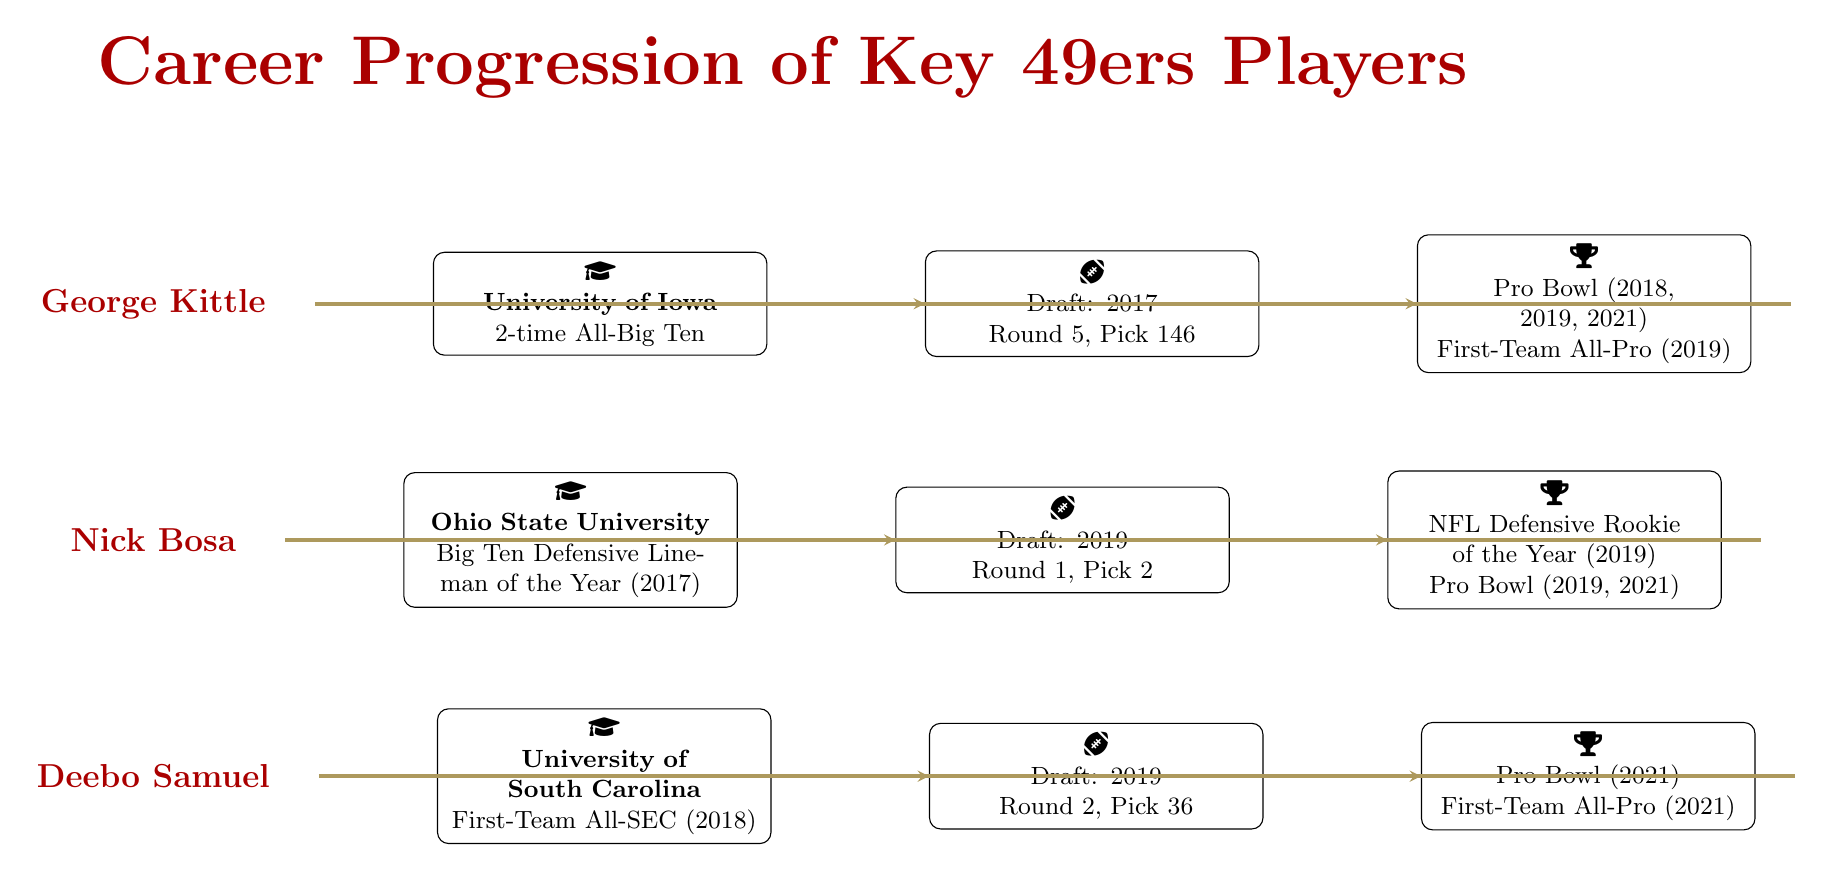What is the college of George Kittle? The diagram indicates that George Kittle attended the University of Iowa, as seen in the section corresponding to his college career.
Answer: University of Iowa How many Pro Bowl selections does Nick Bosa have? The milestone section for Nick Bosa lists his Pro Bowl selections as 2019 and 2021, which are two separate years. Therefore, he has two Pro Bowl selections.
Answer: 2 What year was Deebo Samuel drafted? The draft selection section for Deebo Samuel states the year he was drafted is 2019. Thus, the answer is directly pulled from that section of the diagram.
Answer: 2019 Which player has the highest draft pick number? The diagram shows that Nick Bosa was drafted in the first round with the second pick, which is the highest draft pick number among the listed players in the diagram. Other players have lower picks.
Answer: Nick Bosa How many All-Pro selections does George Kittle have? In the NFL accomplishments section for George Kittle, it specifies that he has one First-Team All-Pro selection in 2019, so the total is exactly one.
Answer: 1 What college highlight did Deebo Samuel achieve? The college career section for Deebo Samuel notes that he was named First-Team All-SEC in 2018, which is categorized as his college highlight.
Answer: First-Team All-SEC What are the total number of types of milestones listed in the diagram? Examining the milestones for each player, the diagram lists "Pro Bowl" and "First-Team All-Pro" as types of milestones. By considering all milestones together, the total is three distinct accomplishments mentioned.
Answer: 3 Which player was drafted in the second round? Looking at the draft selection section, Deebo Samuel was drafted in the second round (round 2, pick 36) as indicated in the diagram.
Answer: Deebo Samuel 